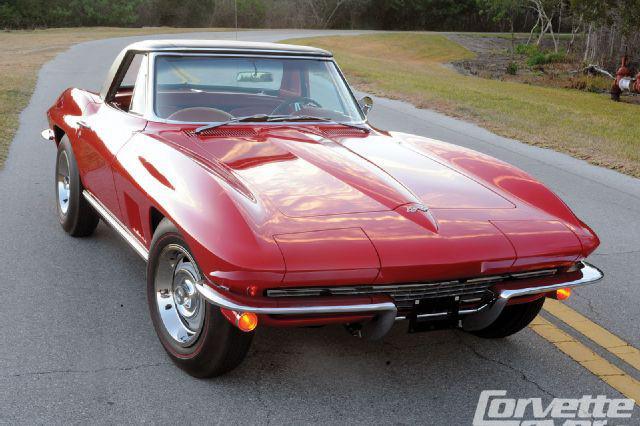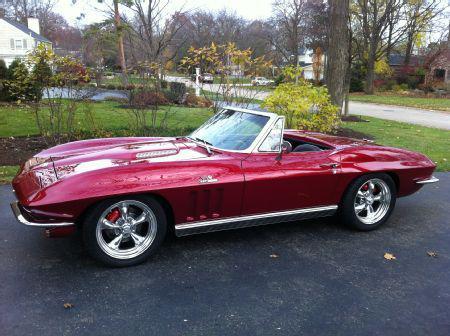The first image is the image on the left, the second image is the image on the right. Examine the images to the left and right. Is the description "The left image features a rightward-angled dark red convertible with its top covered, and the right image shows a leftward-facing dark red convertible with its top down." accurate? Answer yes or no. Yes. 